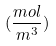<formula> <loc_0><loc_0><loc_500><loc_500>( \frac { m o l } { m ^ { 3 } } )</formula> 